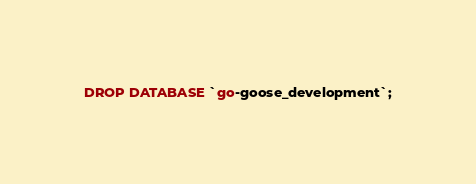<code> <loc_0><loc_0><loc_500><loc_500><_SQL_>DROP DATABASE `go-goose_development`;
</code> 